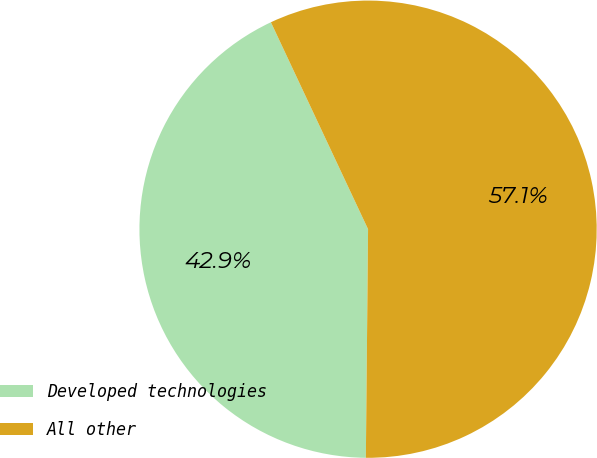<chart> <loc_0><loc_0><loc_500><loc_500><pie_chart><fcel>Developed technologies<fcel>All other<nl><fcel>42.86%<fcel>57.14%<nl></chart> 